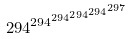<formula> <loc_0><loc_0><loc_500><loc_500>2 9 4 ^ { 2 9 4 ^ { 2 9 4 ^ { 2 9 4 ^ { 2 9 4 ^ { 2 9 7 } } } } }</formula> 